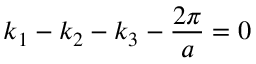Convert formula to latex. <formula><loc_0><loc_0><loc_500><loc_500>k _ { 1 } - k _ { 2 } - k _ { 3 } - \frac { 2 \pi } { a } = 0</formula> 